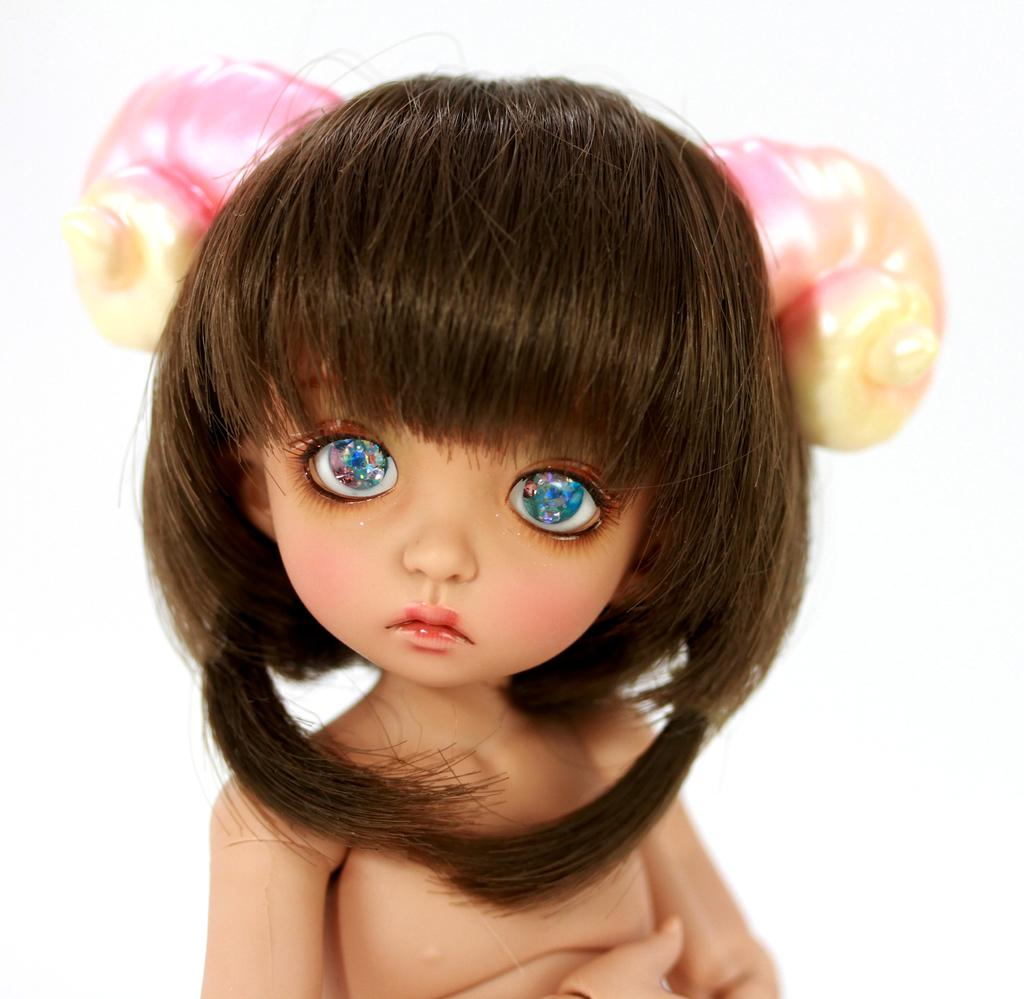What is present in the image? There is a doll in the image. What color are the doll's eyes? The doll has blue eyes. What color is the background of the doll? The background of the doll is white. What type of stocking can be seen on the doll's legs in the image? There is no stocking visible on the doll's legs in the image. What type of railway is present in the image? There is no railway present in the image. What type of relation does the doll have with the person taking the picture? The provided facts do not give any information about the doll's relation to the person taking the picture. 